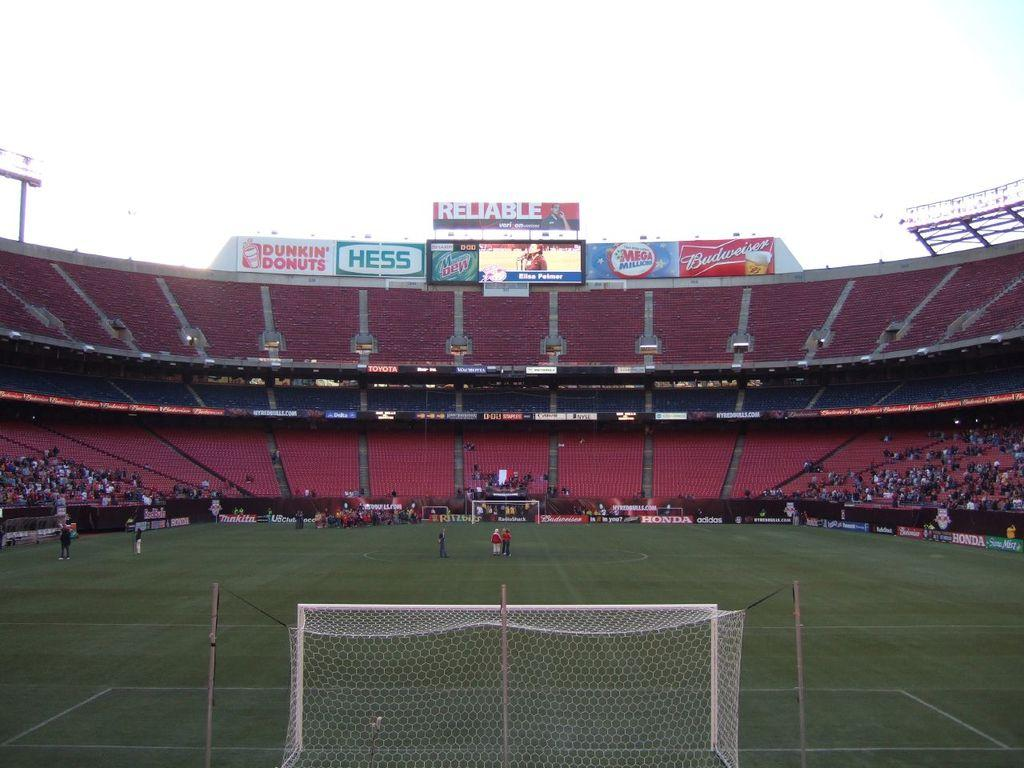<image>
Describe the image concisely. A stadum that promotes Hess, Dunkin Donuts, Mr Dew and Mega Millions. 